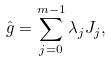<formula> <loc_0><loc_0><loc_500><loc_500>\hat { g } = \sum _ { j = 0 } ^ { m - 1 } \lambda _ { j } J _ { j } ,</formula> 